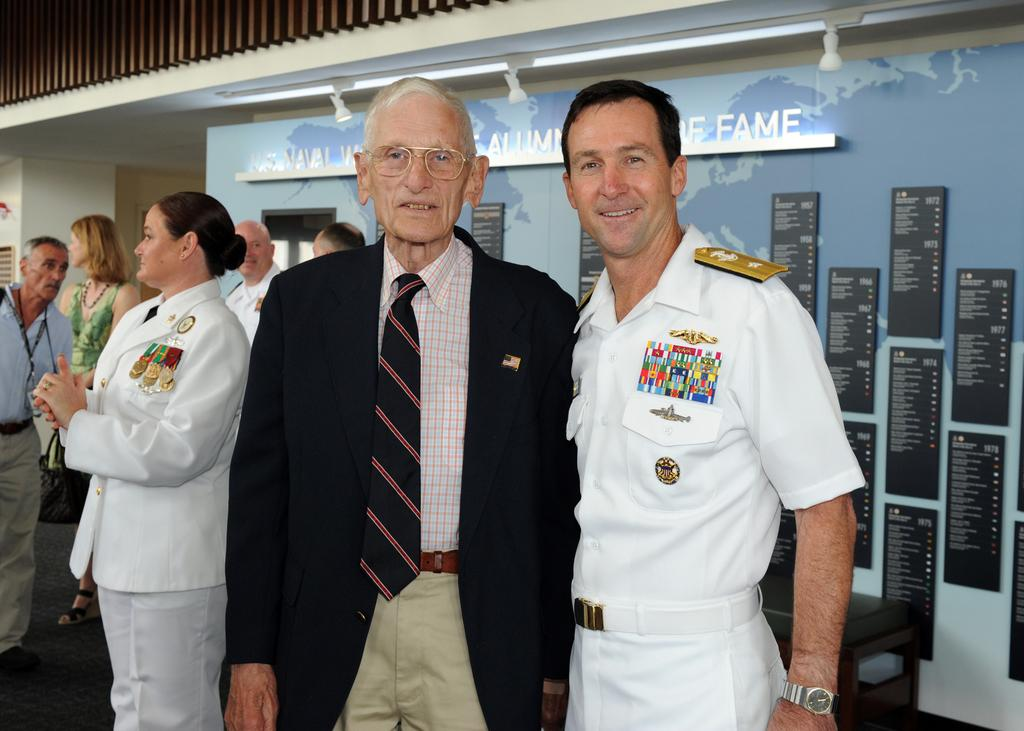<image>
Provide a brief description of the given image. An elderly man poses for a picture with a man in uniform in front of a naval hall of fame sign 